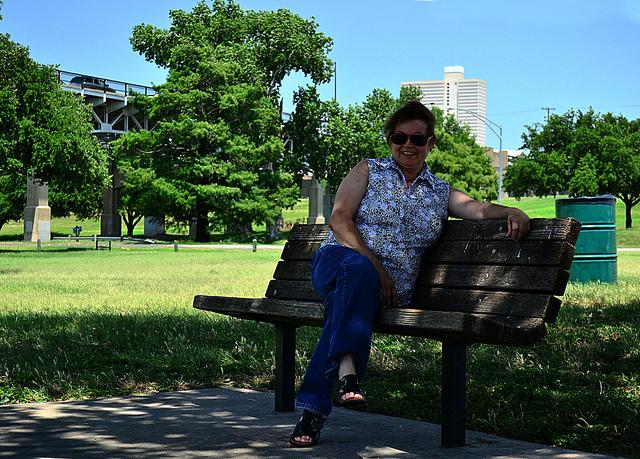What forms the shadow on the woman? tree 